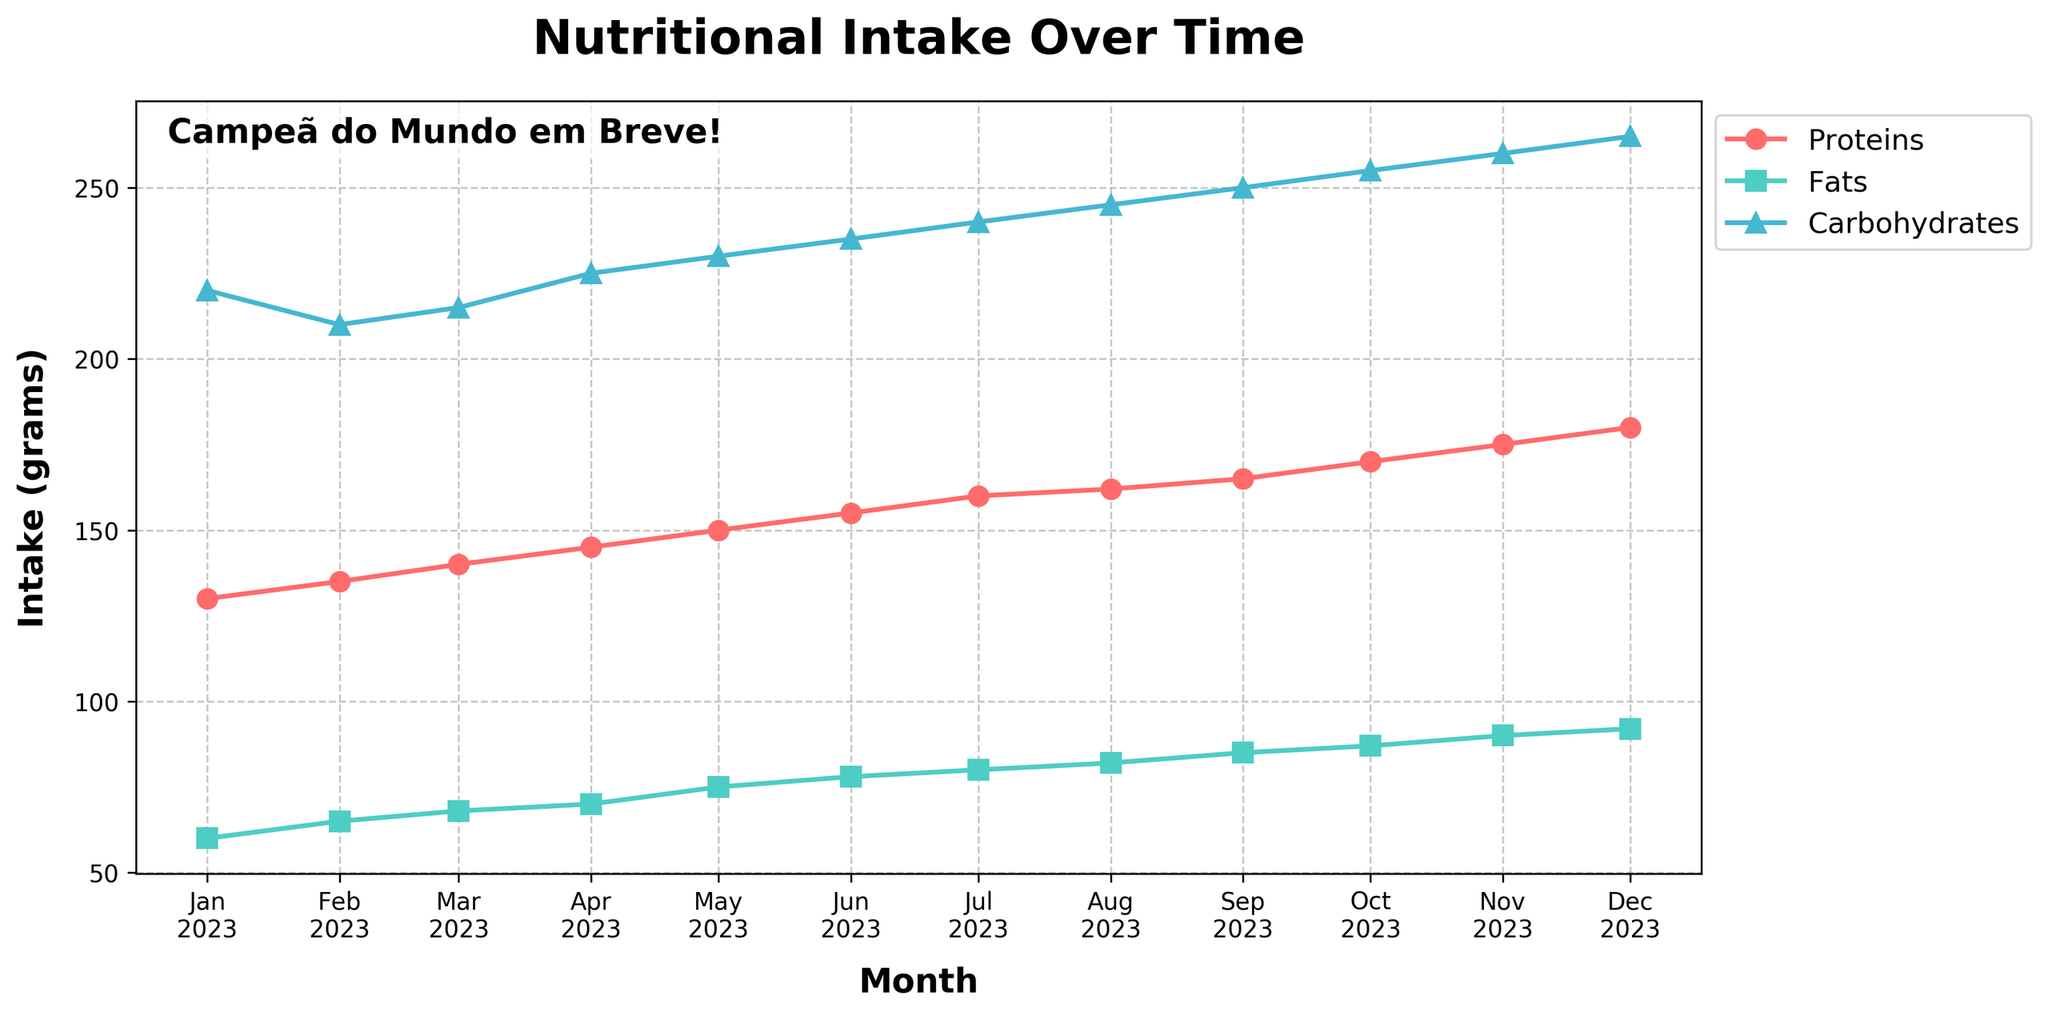What title is displayed on the plot? The title of the plot is located at the top center and is typically descriptive of the content. Here it reads "Nutritional Intake Over Time," which indicates the plot shows how nutritional intake changes over a period.
Answer: Nutritional Intake Over Time How many months of data are presented in the plot? To determine the number of months, count the data points along the x-axis, each representing a specific month from January to December. Therefore, there are 12 months of data.
Answer: 12 Which nutrient has the highest intake in December 2023? Analyze the y-axis values for December 2023, where the plot shows individual points for Proteins, Fats, and Carbohydrates. Carbohydrates have the highest intake at 265 grams as indicated by the specific marker style and color.
Answer: Carbohydrates What is the average intake of proteins for the first half of the year (January to June 2023)? Calculate the sum of protein intakes from January to June (130 + 135 + 140 + 145 + 150 + 155 = 855), then divide by 6 to find the average (855 / 6).
Answer: 142.5 grams How do the protein and fat intakes in July 2023 compare? Refer to the y-axis values for July 2023, where protein intake is at 160 grams and fat intake is at 80 grams. Proteins are double the intake of fats.
Answer: Proteins are double the intake of fats Which month shows the largest increase in carbohydrate intake from the previous month? Calculate the month-to-month differences in carbohydrate intake, then identify the largest: 
January to February = -10 
February to March = 5 
March to April = 10 
April to May = 5 
May to June = 5 
June to July = 5 
July to August = 5 
August to September = 5 
September to October = 5 
October to November = 5 
November to December = 5. April to May shows the largest increase of 10 grams.
Answer: April to May What pattern do you observe in the distribution of fat intake over the year? The fat intake consistently increases each month, showing a steady upward trend from 60 grams in January to 92 grams in December. This is indicative of a consistent dietary increment over each month.
Answer: Steady increase In which month do proteins, fats, and carbohydrates all show increasing intake values compared to the previous month? Identify the months where there is an increase in all nutrients: The changes for each nutrient show that this happens every month from January to December because the intake of all nutrients consistently increased each month.
Answer: Every month 